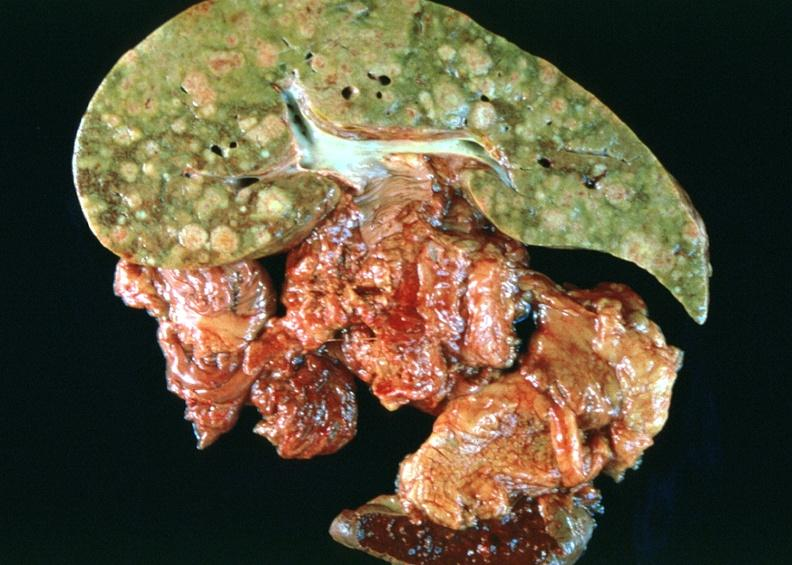does adrenal of premature 30 week gestation gram infant lesion show breast cancer metastasis to liver?
Answer the question using a single word or phrase. No 